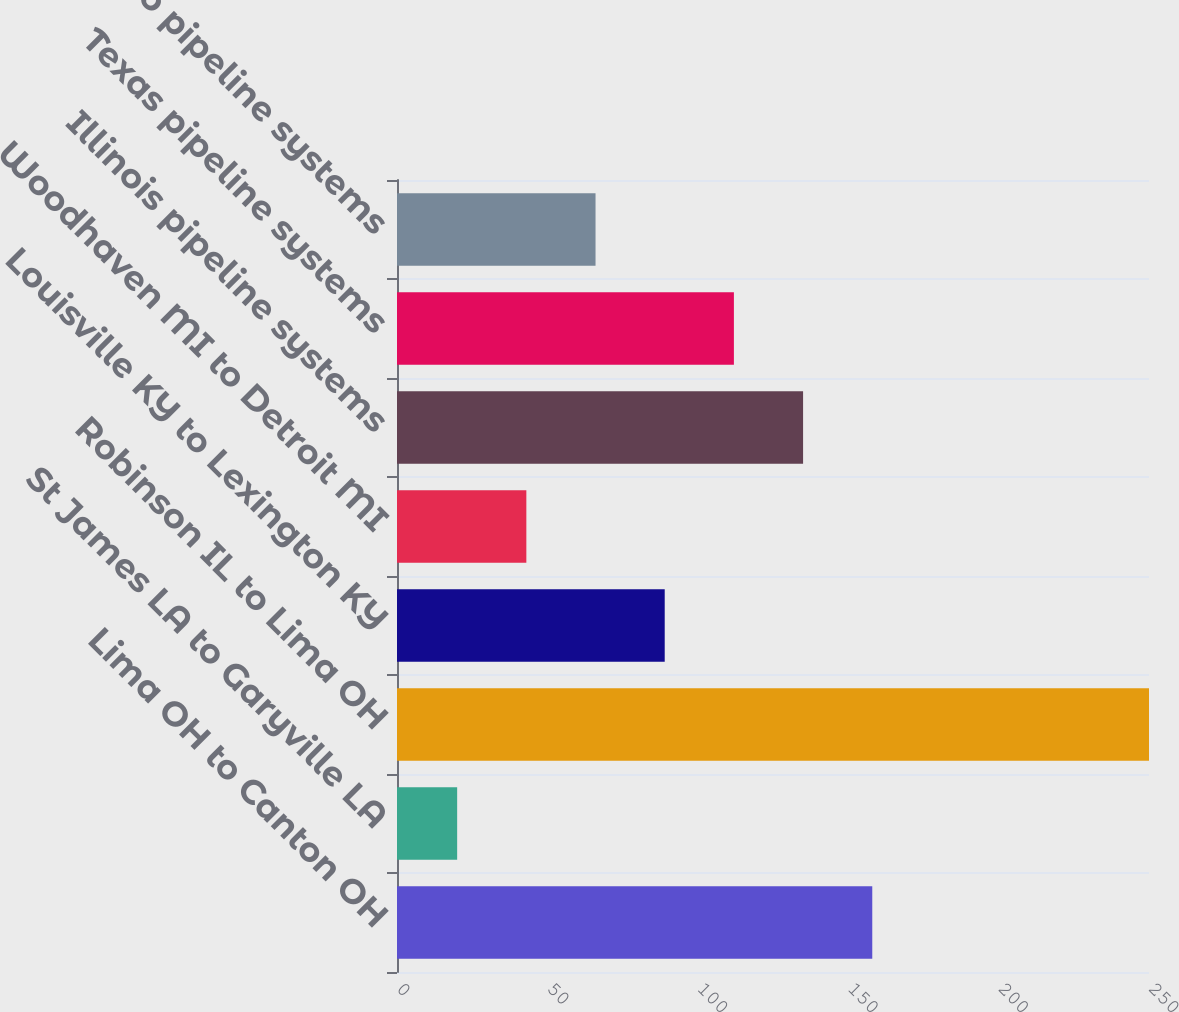Convert chart. <chart><loc_0><loc_0><loc_500><loc_500><bar_chart><fcel>Lima OH to Canton OH<fcel>St James LA to Garyville LA<fcel>Robinson IL to Lima OH<fcel>Louisville KY to Lexington KY<fcel>Woodhaven MI to Detroit MI<fcel>Illinois pipeline systems<fcel>Texas pipeline systems<fcel>Ohio pipeline systems<nl><fcel>158<fcel>20<fcel>250<fcel>89<fcel>43<fcel>135<fcel>112<fcel>66<nl></chart> 